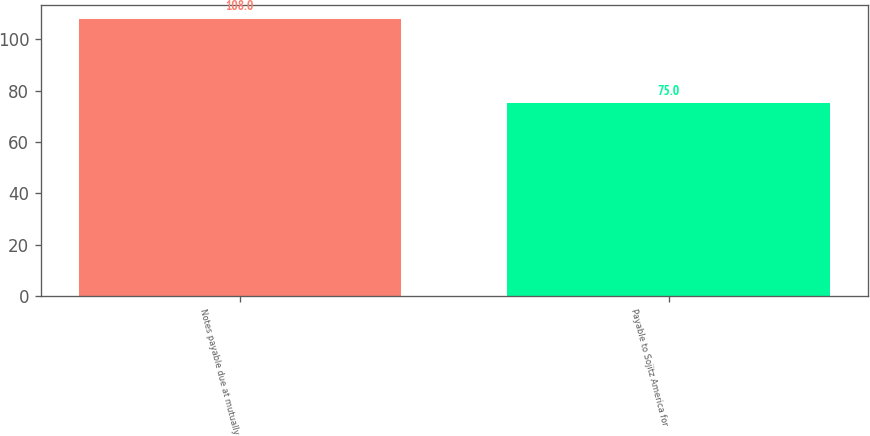<chart> <loc_0><loc_0><loc_500><loc_500><bar_chart><fcel>Notes payable due at mutually<fcel>Payable to Sojitz America for<nl><fcel>108<fcel>75<nl></chart> 